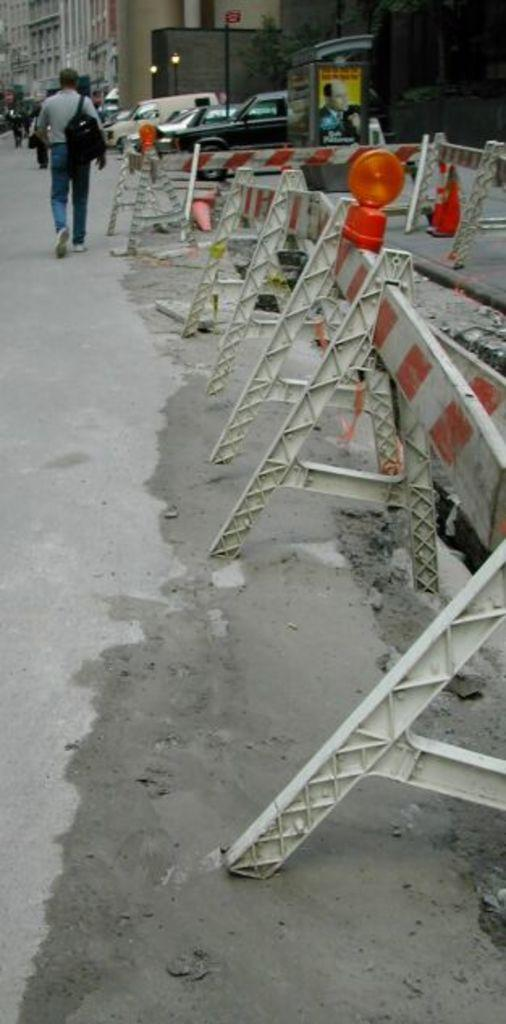What safety-related signs are present on the right side of the image? There are caution boards on the right side of the image. What is the person in the image doing? There is a person walking on a road on the left side of the image. What type of pathway is visible in the image? There is a road in the image. What can be seen in the distance behind the person? Cars and buildings are visible in the background of the image. What type of steel is used to construct the person walking in the image? The person in the image is not made of steel; they are a human being. What is the person's interest in the image? The image does not provide information about the person's interests. 